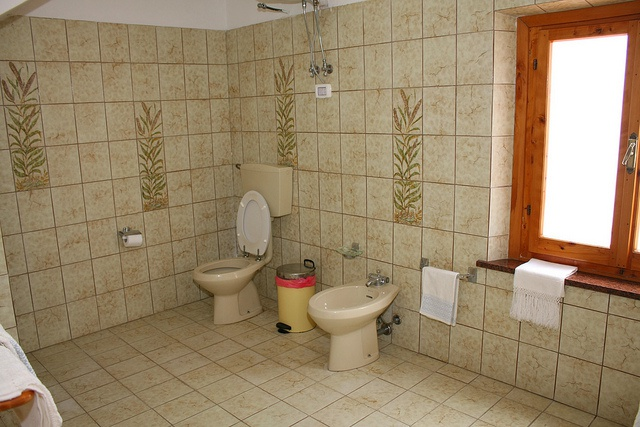Describe the objects in this image and their specific colors. I can see a toilet in darkgray and gray tones in this image. 